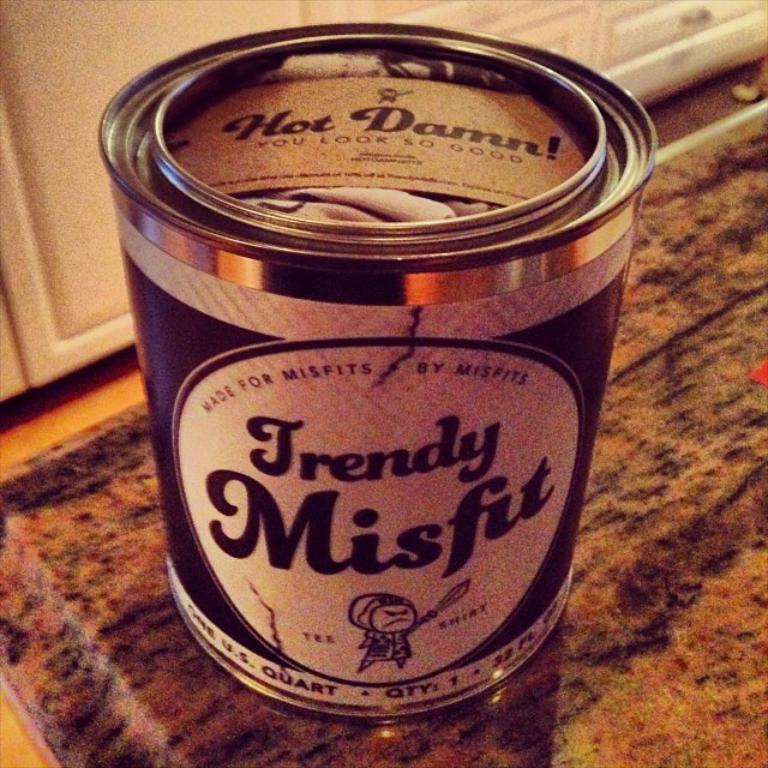What object is present in the image that typically contains a specific substance? There is a can in the image. Can you describe any text or markings on the can? Yes, there is writing on the can. What type of steel is used to manufacture the circle in the image? There is no circle present in the image, and therefore no steel to describe. 